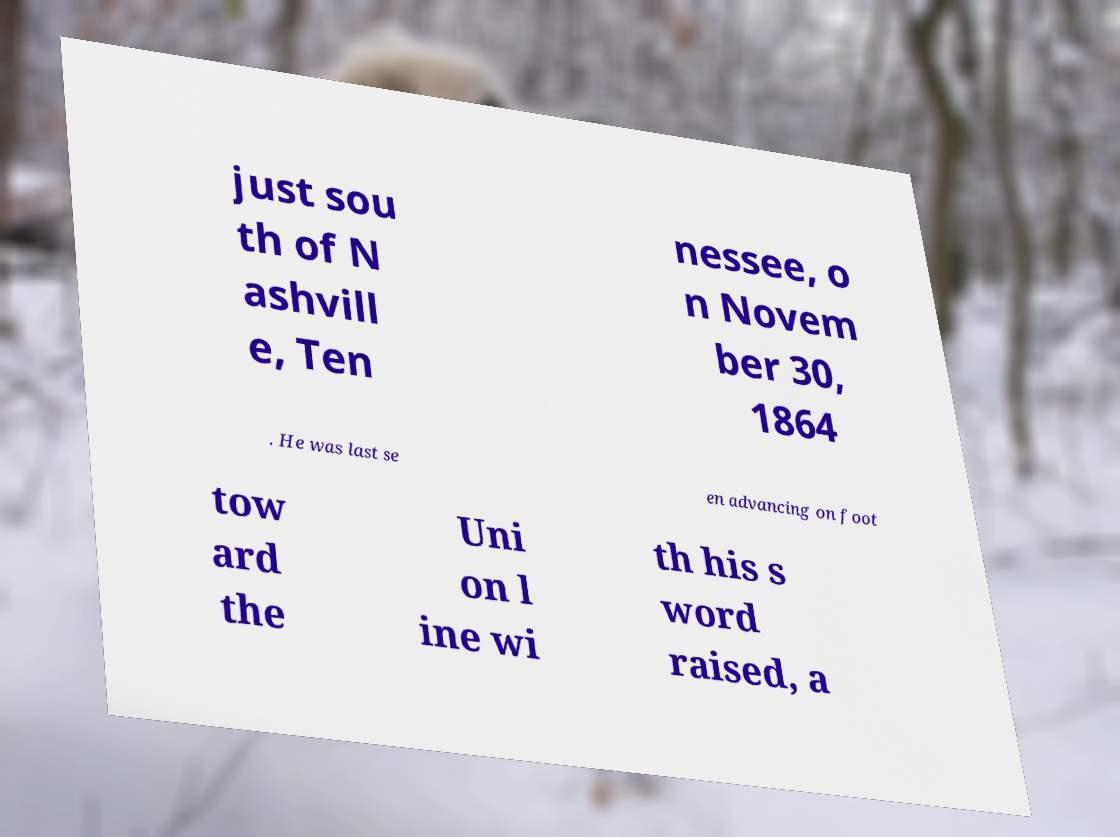Can you accurately transcribe the text from the provided image for me? just sou th of N ashvill e, Ten nessee, o n Novem ber 30, 1864 . He was last se en advancing on foot tow ard the Uni on l ine wi th his s word raised, a 